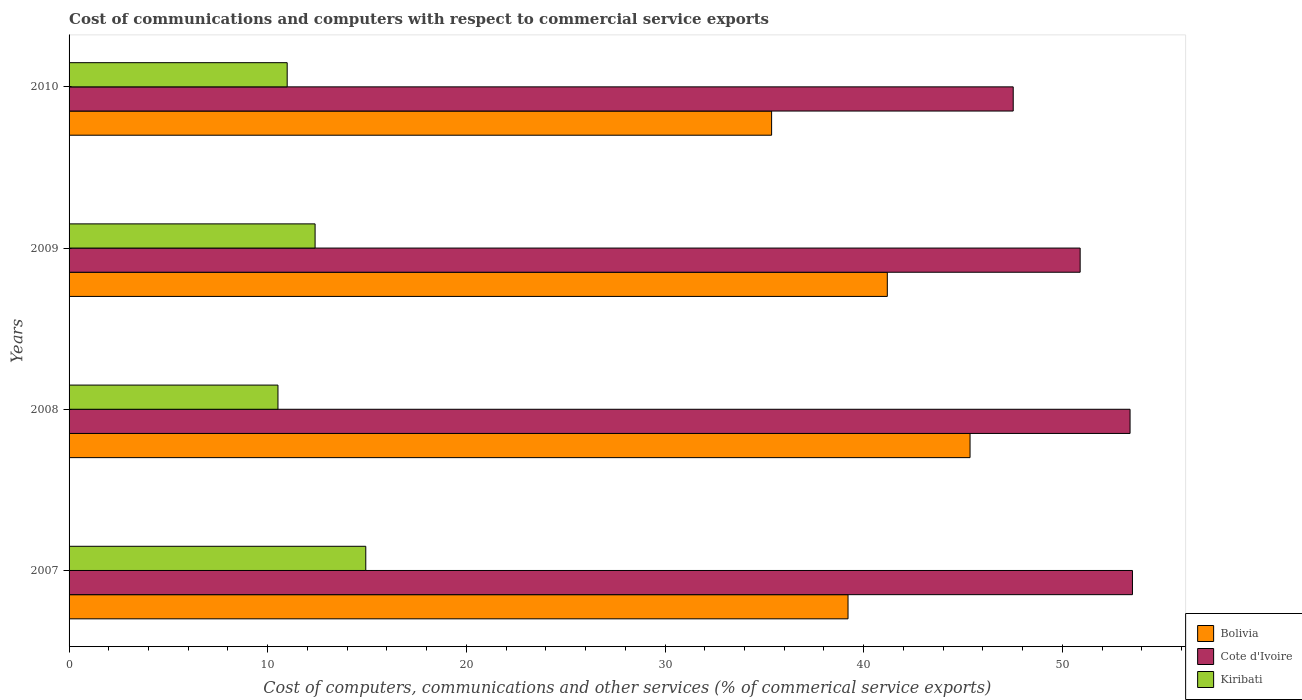How many different coloured bars are there?
Offer a very short reply. 3. Are the number of bars per tick equal to the number of legend labels?
Your answer should be compact. Yes. Are the number of bars on each tick of the Y-axis equal?
Provide a succinct answer. Yes. How many bars are there on the 4th tick from the top?
Your answer should be compact. 3. How many bars are there on the 4th tick from the bottom?
Your answer should be very brief. 3. In how many cases, is the number of bars for a given year not equal to the number of legend labels?
Give a very brief answer. 0. What is the cost of communications and computers in Kiribati in 2009?
Provide a short and direct response. 12.38. Across all years, what is the maximum cost of communications and computers in Bolivia?
Offer a terse response. 45.36. Across all years, what is the minimum cost of communications and computers in Cote d'Ivoire?
Keep it short and to the point. 47.53. In which year was the cost of communications and computers in Kiribati maximum?
Ensure brevity in your answer.  2007. What is the total cost of communications and computers in Kiribati in the graph?
Provide a succinct answer. 48.82. What is the difference between the cost of communications and computers in Bolivia in 2008 and that in 2010?
Offer a very short reply. 9.99. What is the difference between the cost of communications and computers in Kiribati in 2010 and the cost of communications and computers in Bolivia in 2007?
Make the answer very short. -28.23. What is the average cost of communications and computers in Kiribati per year?
Keep it short and to the point. 12.2. In the year 2010, what is the difference between the cost of communications and computers in Bolivia and cost of communications and computers in Cote d'Ivoire?
Give a very brief answer. -12.16. What is the ratio of the cost of communications and computers in Kiribati in 2008 to that in 2009?
Your answer should be compact. 0.85. Is the difference between the cost of communications and computers in Bolivia in 2007 and 2009 greater than the difference between the cost of communications and computers in Cote d'Ivoire in 2007 and 2009?
Ensure brevity in your answer.  No. What is the difference between the highest and the second highest cost of communications and computers in Cote d'Ivoire?
Provide a short and direct response. 0.12. What is the difference between the highest and the lowest cost of communications and computers in Cote d'Ivoire?
Make the answer very short. 6. What does the 2nd bar from the top in 2010 represents?
Provide a short and direct response. Cote d'Ivoire. What does the 3rd bar from the bottom in 2008 represents?
Make the answer very short. Kiribati. Where does the legend appear in the graph?
Your answer should be compact. Bottom right. How many legend labels are there?
Provide a succinct answer. 3. How are the legend labels stacked?
Provide a succinct answer. Vertical. What is the title of the graph?
Offer a very short reply. Cost of communications and computers with respect to commercial service exports. Does "Brazil" appear as one of the legend labels in the graph?
Ensure brevity in your answer.  No. What is the label or title of the X-axis?
Make the answer very short. Cost of computers, communications and other services (% of commerical service exports). What is the label or title of the Y-axis?
Provide a succinct answer. Years. What is the Cost of computers, communications and other services (% of commerical service exports) of Bolivia in 2007?
Keep it short and to the point. 39.21. What is the Cost of computers, communications and other services (% of commerical service exports) of Cote d'Ivoire in 2007?
Your answer should be very brief. 53.53. What is the Cost of computers, communications and other services (% of commerical service exports) in Kiribati in 2007?
Provide a succinct answer. 14.94. What is the Cost of computers, communications and other services (% of commerical service exports) of Bolivia in 2008?
Offer a very short reply. 45.36. What is the Cost of computers, communications and other services (% of commerical service exports) in Cote d'Ivoire in 2008?
Your response must be concise. 53.41. What is the Cost of computers, communications and other services (% of commerical service exports) in Kiribati in 2008?
Provide a short and direct response. 10.52. What is the Cost of computers, communications and other services (% of commerical service exports) in Bolivia in 2009?
Keep it short and to the point. 41.19. What is the Cost of computers, communications and other services (% of commerical service exports) of Cote d'Ivoire in 2009?
Keep it short and to the point. 50.9. What is the Cost of computers, communications and other services (% of commerical service exports) of Kiribati in 2009?
Keep it short and to the point. 12.38. What is the Cost of computers, communications and other services (% of commerical service exports) of Bolivia in 2010?
Give a very brief answer. 35.37. What is the Cost of computers, communications and other services (% of commerical service exports) in Cote d'Ivoire in 2010?
Keep it short and to the point. 47.53. What is the Cost of computers, communications and other services (% of commerical service exports) of Kiribati in 2010?
Give a very brief answer. 10.98. Across all years, what is the maximum Cost of computers, communications and other services (% of commerical service exports) of Bolivia?
Your response must be concise. 45.36. Across all years, what is the maximum Cost of computers, communications and other services (% of commerical service exports) of Cote d'Ivoire?
Offer a terse response. 53.53. Across all years, what is the maximum Cost of computers, communications and other services (% of commerical service exports) of Kiribati?
Your answer should be compact. 14.94. Across all years, what is the minimum Cost of computers, communications and other services (% of commerical service exports) of Bolivia?
Keep it short and to the point. 35.37. Across all years, what is the minimum Cost of computers, communications and other services (% of commerical service exports) of Cote d'Ivoire?
Offer a terse response. 47.53. Across all years, what is the minimum Cost of computers, communications and other services (% of commerical service exports) in Kiribati?
Your response must be concise. 10.52. What is the total Cost of computers, communications and other services (% of commerical service exports) of Bolivia in the graph?
Offer a very short reply. 161.13. What is the total Cost of computers, communications and other services (% of commerical service exports) in Cote d'Ivoire in the graph?
Offer a terse response. 205.37. What is the total Cost of computers, communications and other services (% of commerical service exports) of Kiribati in the graph?
Offer a very short reply. 48.82. What is the difference between the Cost of computers, communications and other services (% of commerical service exports) in Bolivia in 2007 and that in 2008?
Your answer should be very brief. -6.14. What is the difference between the Cost of computers, communications and other services (% of commerical service exports) in Cote d'Ivoire in 2007 and that in 2008?
Provide a succinct answer. 0.12. What is the difference between the Cost of computers, communications and other services (% of commerical service exports) of Kiribati in 2007 and that in 2008?
Offer a very short reply. 4.42. What is the difference between the Cost of computers, communications and other services (% of commerical service exports) of Bolivia in 2007 and that in 2009?
Keep it short and to the point. -1.98. What is the difference between the Cost of computers, communications and other services (% of commerical service exports) of Cote d'Ivoire in 2007 and that in 2009?
Give a very brief answer. 2.63. What is the difference between the Cost of computers, communications and other services (% of commerical service exports) of Kiribati in 2007 and that in 2009?
Give a very brief answer. 2.55. What is the difference between the Cost of computers, communications and other services (% of commerical service exports) in Bolivia in 2007 and that in 2010?
Offer a terse response. 3.85. What is the difference between the Cost of computers, communications and other services (% of commerical service exports) of Cote d'Ivoire in 2007 and that in 2010?
Ensure brevity in your answer.  6. What is the difference between the Cost of computers, communications and other services (% of commerical service exports) of Kiribati in 2007 and that in 2010?
Keep it short and to the point. 3.96. What is the difference between the Cost of computers, communications and other services (% of commerical service exports) in Bolivia in 2008 and that in 2009?
Offer a terse response. 4.16. What is the difference between the Cost of computers, communications and other services (% of commerical service exports) of Cote d'Ivoire in 2008 and that in 2009?
Your answer should be very brief. 2.51. What is the difference between the Cost of computers, communications and other services (% of commerical service exports) in Kiribati in 2008 and that in 2009?
Provide a succinct answer. -1.87. What is the difference between the Cost of computers, communications and other services (% of commerical service exports) of Bolivia in 2008 and that in 2010?
Keep it short and to the point. 9.99. What is the difference between the Cost of computers, communications and other services (% of commerical service exports) of Cote d'Ivoire in 2008 and that in 2010?
Your answer should be very brief. 5.88. What is the difference between the Cost of computers, communications and other services (% of commerical service exports) in Kiribati in 2008 and that in 2010?
Ensure brevity in your answer.  -0.46. What is the difference between the Cost of computers, communications and other services (% of commerical service exports) in Bolivia in 2009 and that in 2010?
Ensure brevity in your answer.  5.82. What is the difference between the Cost of computers, communications and other services (% of commerical service exports) of Cote d'Ivoire in 2009 and that in 2010?
Your answer should be very brief. 3.37. What is the difference between the Cost of computers, communications and other services (% of commerical service exports) of Kiribati in 2009 and that in 2010?
Your response must be concise. 1.41. What is the difference between the Cost of computers, communications and other services (% of commerical service exports) in Bolivia in 2007 and the Cost of computers, communications and other services (% of commerical service exports) in Cote d'Ivoire in 2008?
Provide a succinct answer. -14.2. What is the difference between the Cost of computers, communications and other services (% of commerical service exports) in Bolivia in 2007 and the Cost of computers, communications and other services (% of commerical service exports) in Kiribati in 2008?
Provide a short and direct response. 28.7. What is the difference between the Cost of computers, communications and other services (% of commerical service exports) in Cote d'Ivoire in 2007 and the Cost of computers, communications and other services (% of commerical service exports) in Kiribati in 2008?
Keep it short and to the point. 43.02. What is the difference between the Cost of computers, communications and other services (% of commerical service exports) in Bolivia in 2007 and the Cost of computers, communications and other services (% of commerical service exports) in Cote d'Ivoire in 2009?
Your answer should be compact. -11.68. What is the difference between the Cost of computers, communications and other services (% of commerical service exports) of Bolivia in 2007 and the Cost of computers, communications and other services (% of commerical service exports) of Kiribati in 2009?
Your answer should be compact. 26.83. What is the difference between the Cost of computers, communications and other services (% of commerical service exports) of Cote d'Ivoire in 2007 and the Cost of computers, communications and other services (% of commerical service exports) of Kiribati in 2009?
Ensure brevity in your answer.  41.15. What is the difference between the Cost of computers, communications and other services (% of commerical service exports) of Bolivia in 2007 and the Cost of computers, communications and other services (% of commerical service exports) of Cote d'Ivoire in 2010?
Your response must be concise. -8.32. What is the difference between the Cost of computers, communications and other services (% of commerical service exports) of Bolivia in 2007 and the Cost of computers, communications and other services (% of commerical service exports) of Kiribati in 2010?
Keep it short and to the point. 28.23. What is the difference between the Cost of computers, communications and other services (% of commerical service exports) in Cote d'Ivoire in 2007 and the Cost of computers, communications and other services (% of commerical service exports) in Kiribati in 2010?
Provide a short and direct response. 42.55. What is the difference between the Cost of computers, communications and other services (% of commerical service exports) of Bolivia in 2008 and the Cost of computers, communications and other services (% of commerical service exports) of Cote d'Ivoire in 2009?
Offer a terse response. -5.54. What is the difference between the Cost of computers, communications and other services (% of commerical service exports) of Bolivia in 2008 and the Cost of computers, communications and other services (% of commerical service exports) of Kiribati in 2009?
Offer a very short reply. 32.97. What is the difference between the Cost of computers, communications and other services (% of commerical service exports) of Cote d'Ivoire in 2008 and the Cost of computers, communications and other services (% of commerical service exports) of Kiribati in 2009?
Your response must be concise. 41.03. What is the difference between the Cost of computers, communications and other services (% of commerical service exports) in Bolivia in 2008 and the Cost of computers, communications and other services (% of commerical service exports) in Cote d'Ivoire in 2010?
Offer a terse response. -2.17. What is the difference between the Cost of computers, communications and other services (% of commerical service exports) in Bolivia in 2008 and the Cost of computers, communications and other services (% of commerical service exports) in Kiribati in 2010?
Ensure brevity in your answer.  34.38. What is the difference between the Cost of computers, communications and other services (% of commerical service exports) of Cote d'Ivoire in 2008 and the Cost of computers, communications and other services (% of commerical service exports) of Kiribati in 2010?
Provide a short and direct response. 42.43. What is the difference between the Cost of computers, communications and other services (% of commerical service exports) of Bolivia in 2009 and the Cost of computers, communications and other services (% of commerical service exports) of Cote d'Ivoire in 2010?
Your answer should be very brief. -6.34. What is the difference between the Cost of computers, communications and other services (% of commerical service exports) of Bolivia in 2009 and the Cost of computers, communications and other services (% of commerical service exports) of Kiribati in 2010?
Provide a short and direct response. 30.21. What is the difference between the Cost of computers, communications and other services (% of commerical service exports) in Cote d'Ivoire in 2009 and the Cost of computers, communications and other services (% of commerical service exports) in Kiribati in 2010?
Offer a terse response. 39.92. What is the average Cost of computers, communications and other services (% of commerical service exports) in Bolivia per year?
Ensure brevity in your answer.  40.28. What is the average Cost of computers, communications and other services (% of commerical service exports) of Cote d'Ivoire per year?
Offer a very short reply. 51.34. What is the average Cost of computers, communications and other services (% of commerical service exports) in Kiribati per year?
Make the answer very short. 12.2. In the year 2007, what is the difference between the Cost of computers, communications and other services (% of commerical service exports) in Bolivia and Cost of computers, communications and other services (% of commerical service exports) in Cote d'Ivoire?
Ensure brevity in your answer.  -14.32. In the year 2007, what is the difference between the Cost of computers, communications and other services (% of commerical service exports) of Bolivia and Cost of computers, communications and other services (% of commerical service exports) of Kiribati?
Your answer should be compact. 24.28. In the year 2007, what is the difference between the Cost of computers, communications and other services (% of commerical service exports) of Cote d'Ivoire and Cost of computers, communications and other services (% of commerical service exports) of Kiribati?
Offer a terse response. 38.59. In the year 2008, what is the difference between the Cost of computers, communications and other services (% of commerical service exports) of Bolivia and Cost of computers, communications and other services (% of commerical service exports) of Cote d'Ivoire?
Offer a very short reply. -8.05. In the year 2008, what is the difference between the Cost of computers, communications and other services (% of commerical service exports) of Bolivia and Cost of computers, communications and other services (% of commerical service exports) of Kiribati?
Make the answer very short. 34.84. In the year 2008, what is the difference between the Cost of computers, communications and other services (% of commerical service exports) of Cote d'Ivoire and Cost of computers, communications and other services (% of commerical service exports) of Kiribati?
Offer a terse response. 42.89. In the year 2009, what is the difference between the Cost of computers, communications and other services (% of commerical service exports) of Bolivia and Cost of computers, communications and other services (% of commerical service exports) of Cote d'Ivoire?
Your response must be concise. -9.71. In the year 2009, what is the difference between the Cost of computers, communications and other services (% of commerical service exports) of Bolivia and Cost of computers, communications and other services (% of commerical service exports) of Kiribati?
Provide a succinct answer. 28.81. In the year 2009, what is the difference between the Cost of computers, communications and other services (% of commerical service exports) in Cote d'Ivoire and Cost of computers, communications and other services (% of commerical service exports) in Kiribati?
Your response must be concise. 38.51. In the year 2010, what is the difference between the Cost of computers, communications and other services (% of commerical service exports) of Bolivia and Cost of computers, communications and other services (% of commerical service exports) of Cote d'Ivoire?
Give a very brief answer. -12.16. In the year 2010, what is the difference between the Cost of computers, communications and other services (% of commerical service exports) of Bolivia and Cost of computers, communications and other services (% of commerical service exports) of Kiribati?
Offer a terse response. 24.39. In the year 2010, what is the difference between the Cost of computers, communications and other services (% of commerical service exports) of Cote d'Ivoire and Cost of computers, communications and other services (% of commerical service exports) of Kiribati?
Ensure brevity in your answer.  36.55. What is the ratio of the Cost of computers, communications and other services (% of commerical service exports) of Bolivia in 2007 to that in 2008?
Make the answer very short. 0.86. What is the ratio of the Cost of computers, communications and other services (% of commerical service exports) of Kiribati in 2007 to that in 2008?
Give a very brief answer. 1.42. What is the ratio of the Cost of computers, communications and other services (% of commerical service exports) in Cote d'Ivoire in 2007 to that in 2009?
Offer a very short reply. 1.05. What is the ratio of the Cost of computers, communications and other services (% of commerical service exports) in Kiribati in 2007 to that in 2009?
Offer a very short reply. 1.21. What is the ratio of the Cost of computers, communications and other services (% of commerical service exports) in Bolivia in 2007 to that in 2010?
Your answer should be very brief. 1.11. What is the ratio of the Cost of computers, communications and other services (% of commerical service exports) of Cote d'Ivoire in 2007 to that in 2010?
Provide a short and direct response. 1.13. What is the ratio of the Cost of computers, communications and other services (% of commerical service exports) in Kiribati in 2007 to that in 2010?
Make the answer very short. 1.36. What is the ratio of the Cost of computers, communications and other services (% of commerical service exports) in Bolivia in 2008 to that in 2009?
Your response must be concise. 1.1. What is the ratio of the Cost of computers, communications and other services (% of commerical service exports) of Cote d'Ivoire in 2008 to that in 2009?
Offer a very short reply. 1.05. What is the ratio of the Cost of computers, communications and other services (% of commerical service exports) in Kiribati in 2008 to that in 2009?
Your answer should be compact. 0.85. What is the ratio of the Cost of computers, communications and other services (% of commerical service exports) in Bolivia in 2008 to that in 2010?
Your answer should be compact. 1.28. What is the ratio of the Cost of computers, communications and other services (% of commerical service exports) of Cote d'Ivoire in 2008 to that in 2010?
Your answer should be compact. 1.12. What is the ratio of the Cost of computers, communications and other services (% of commerical service exports) in Kiribati in 2008 to that in 2010?
Your answer should be compact. 0.96. What is the ratio of the Cost of computers, communications and other services (% of commerical service exports) of Bolivia in 2009 to that in 2010?
Give a very brief answer. 1.16. What is the ratio of the Cost of computers, communications and other services (% of commerical service exports) of Cote d'Ivoire in 2009 to that in 2010?
Ensure brevity in your answer.  1.07. What is the ratio of the Cost of computers, communications and other services (% of commerical service exports) of Kiribati in 2009 to that in 2010?
Give a very brief answer. 1.13. What is the difference between the highest and the second highest Cost of computers, communications and other services (% of commerical service exports) of Bolivia?
Provide a short and direct response. 4.16. What is the difference between the highest and the second highest Cost of computers, communications and other services (% of commerical service exports) of Cote d'Ivoire?
Keep it short and to the point. 0.12. What is the difference between the highest and the second highest Cost of computers, communications and other services (% of commerical service exports) in Kiribati?
Your response must be concise. 2.55. What is the difference between the highest and the lowest Cost of computers, communications and other services (% of commerical service exports) in Bolivia?
Give a very brief answer. 9.99. What is the difference between the highest and the lowest Cost of computers, communications and other services (% of commerical service exports) in Cote d'Ivoire?
Make the answer very short. 6. What is the difference between the highest and the lowest Cost of computers, communications and other services (% of commerical service exports) in Kiribati?
Ensure brevity in your answer.  4.42. 